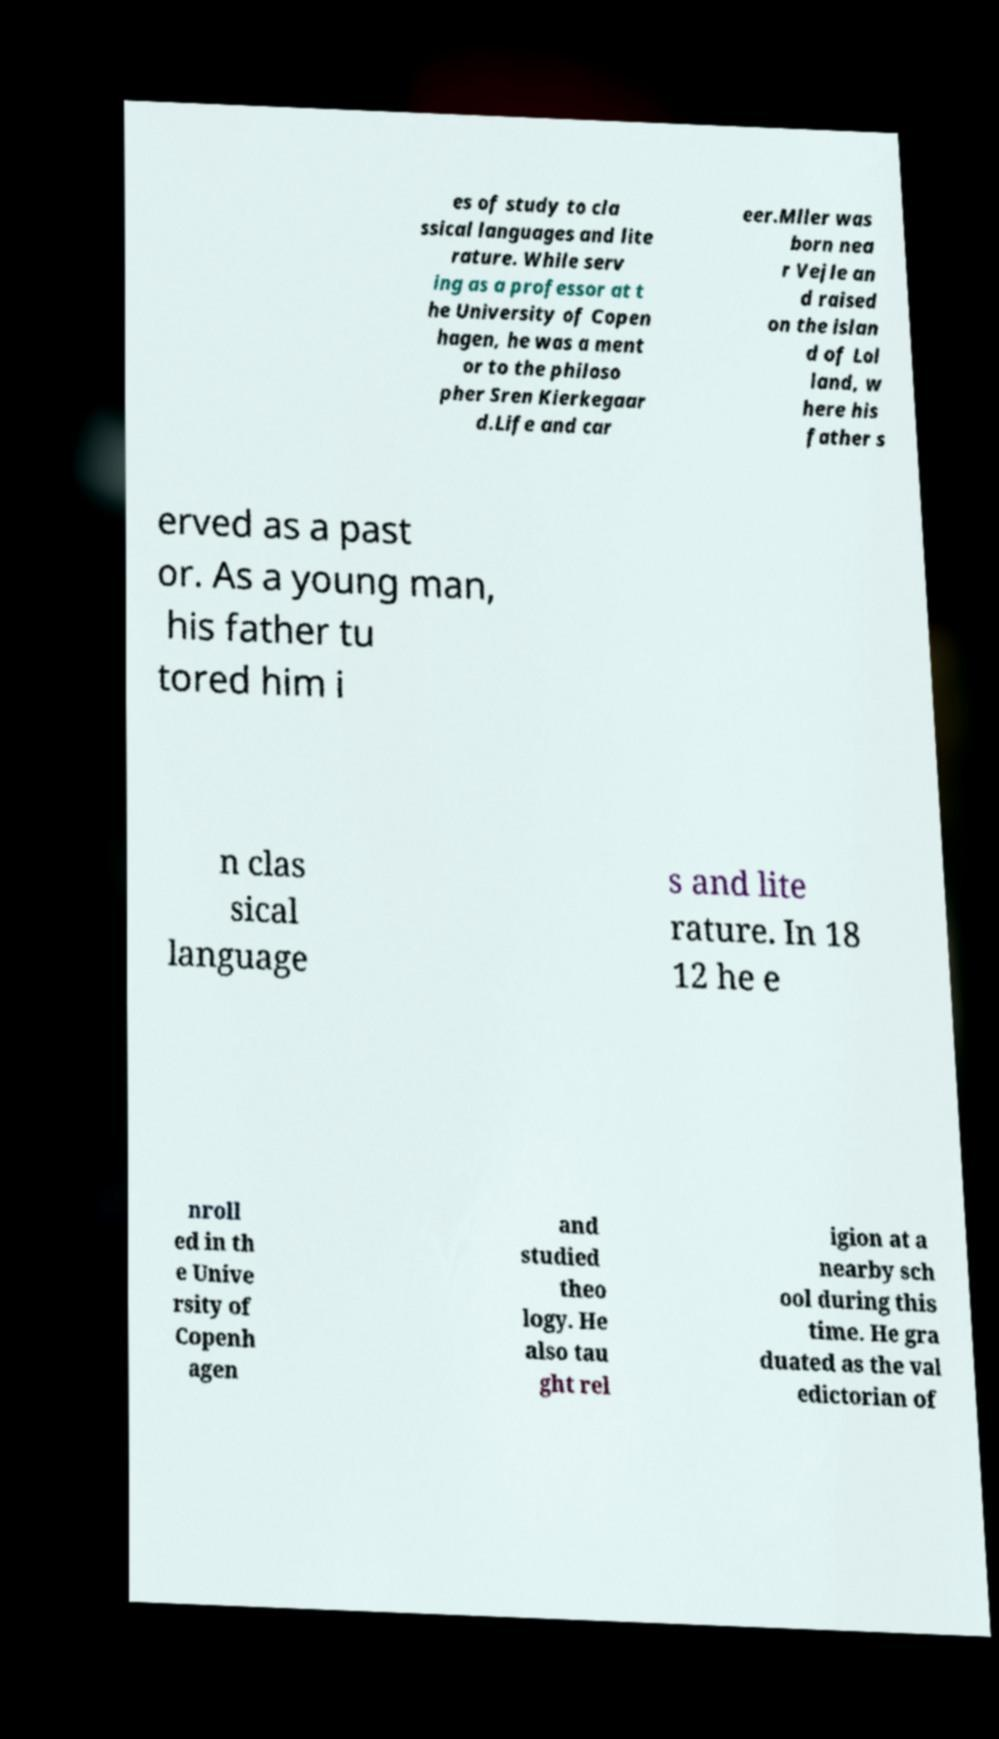What messages or text are displayed in this image? I need them in a readable, typed format. es of study to cla ssical languages and lite rature. While serv ing as a professor at t he University of Copen hagen, he was a ment or to the philoso pher Sren Kierkegaar d.Life and car eer.Mller was born nea r Vejle an d raised on the islan d of Lol land, w here his father s erved as a past or. As a young man, his father tu tored him i n clas sical language s and lite rature. In 18 12 he e nroll ed in th e Unive rsity of Copenh agen and studied theo logy. He also tau ght rel igion at a nearby sch ool during this time. He gra duated as the val edictorian of 